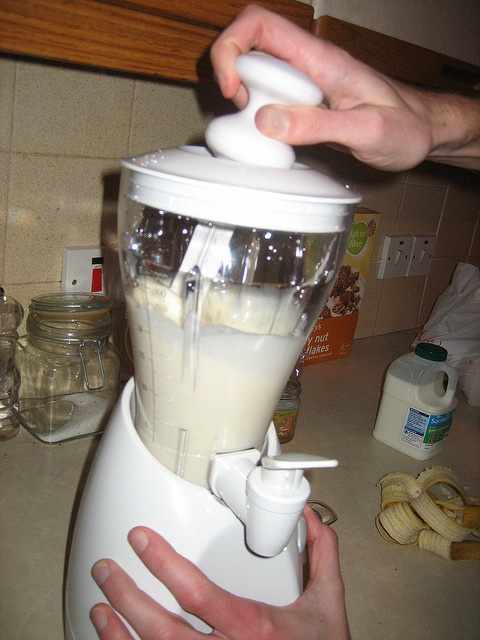Describe the objects in this image and their specific colors. I can see people in maroon, lightpink, gray, and salmon tones, people in maroon, brown, salmon, and darkgray tones, banana in maroon, olive, and gray tones, bottle in maroon, gray, and black tones, and bottle in maroon, olive, gray, and black tones in this image. 